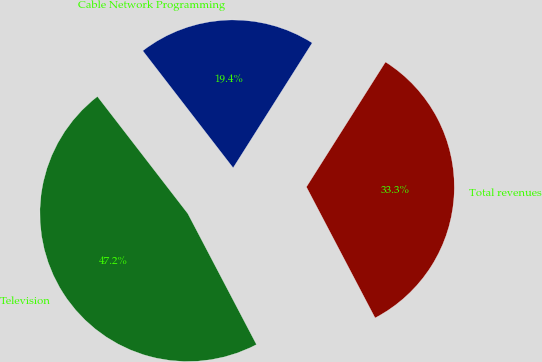Convert chart. <chart><loc_0><loc_0><loc_500><loc_500><pie_chart><fcel>Cable Network Programming<fcel>Television<fcel>Total revenues<nl><fcel>19.44%<fcel>47.22%<fcel>33.33%<nl></chart> 